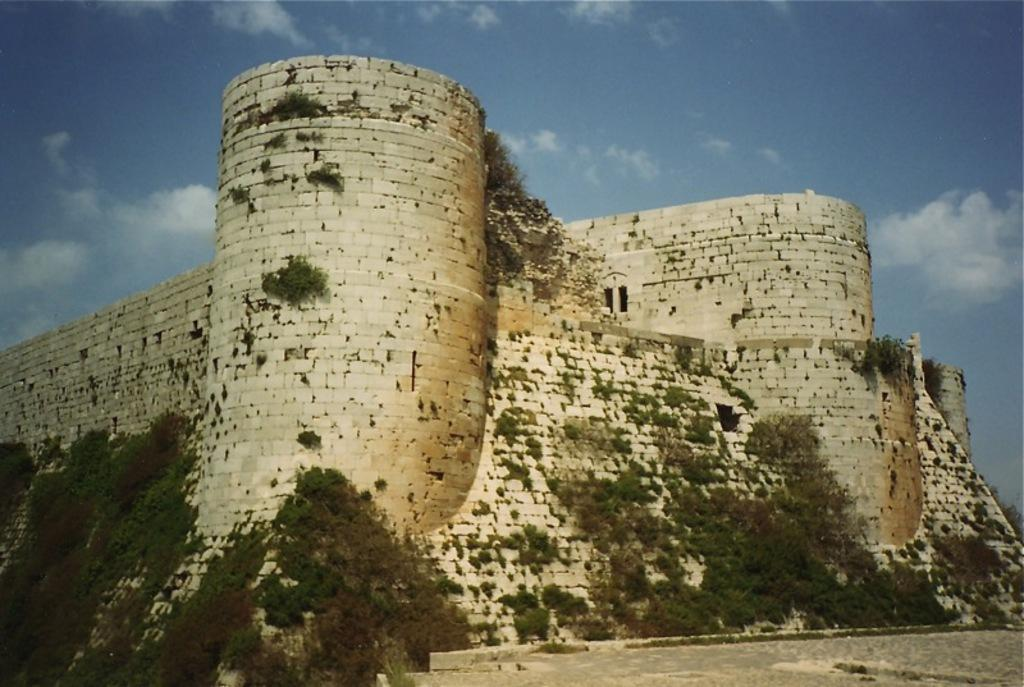What type of structure is present in the image? There is an ancient fort in the image. What is the color of the fort? The fort is in white color. What type of vegetation can be seen on the fort? There is grass on the fort. Can you see a stream flowing near the fort in the image? There is no stream visible in the image; it only shows the ancient fort with grass on it. 